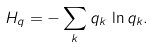<formula> <loc_0><loc_0><loc_500><loc_500>H _ { q } = - \sum _ { k } q _ { k } \, \ln q _ { k } .</formula> 